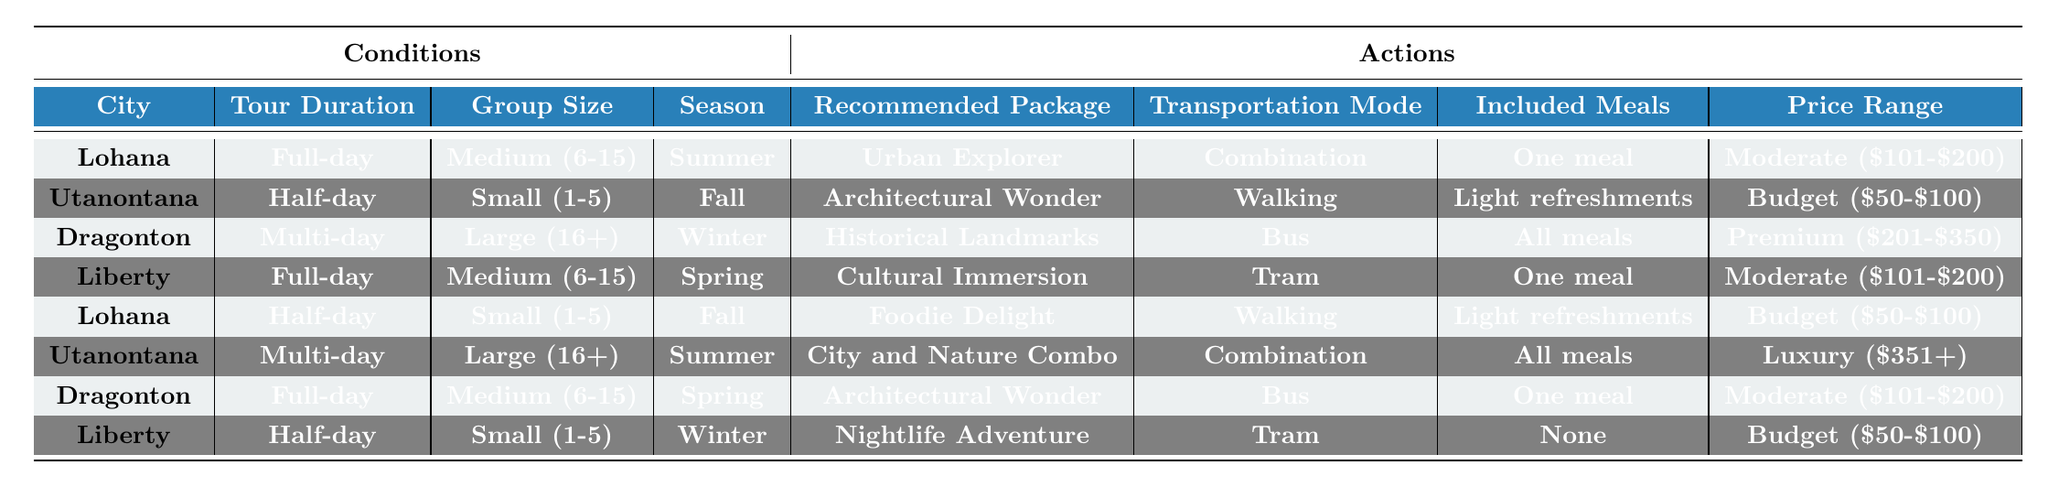What is the recommended package for a Full-day tour in Lohana during Summer? The table shows that for a Full-day tour in Lohana during Summer, the recommended package is "Urban Explorer". This information can be found directly in the first row of the "Recommended Package" column under the specified conditions.
Answer: Urban Explorer How many different transportation modes are listed for the tours? By examining the "Transportation Mode" column in the table, we can see that there are four options available: "Walking", "Bus", "Tram", and "Combination". Thus, there are a total of 4 distinct transportation modes.
Answer: 4 Is there a tour package that provides all meals included for a Full-day tour? Looking at the table, we can see that for a Full-day tour, there are no entries that state "All meals" under the "Included Meals" column. Therefore, the answer is no.
Answer: No What is the price range for the "Nightlife Adventure" package? From the table, it is shown that the "Nightlife Adventure" package is associated with Liberty, during a Half-day tour in Winter. The corresponding price range listed is "Budget ($50-$100)".
Answer: Budget ($50-$100) What is the average group size for the recommended package "Architectural Wonder"? The package "Architectural Wonder" appears connected to two entries in the table: one for Dragonton with a Medium group size and one for Utanontana with a Small group size. Calculating the average, we convert Small (1-5) to 3 and Medium (6-15) to 11, giving us (3 + 11)/2 = 7. This leads us to conclude that the average group size for this package is 7.
Answer: 7 